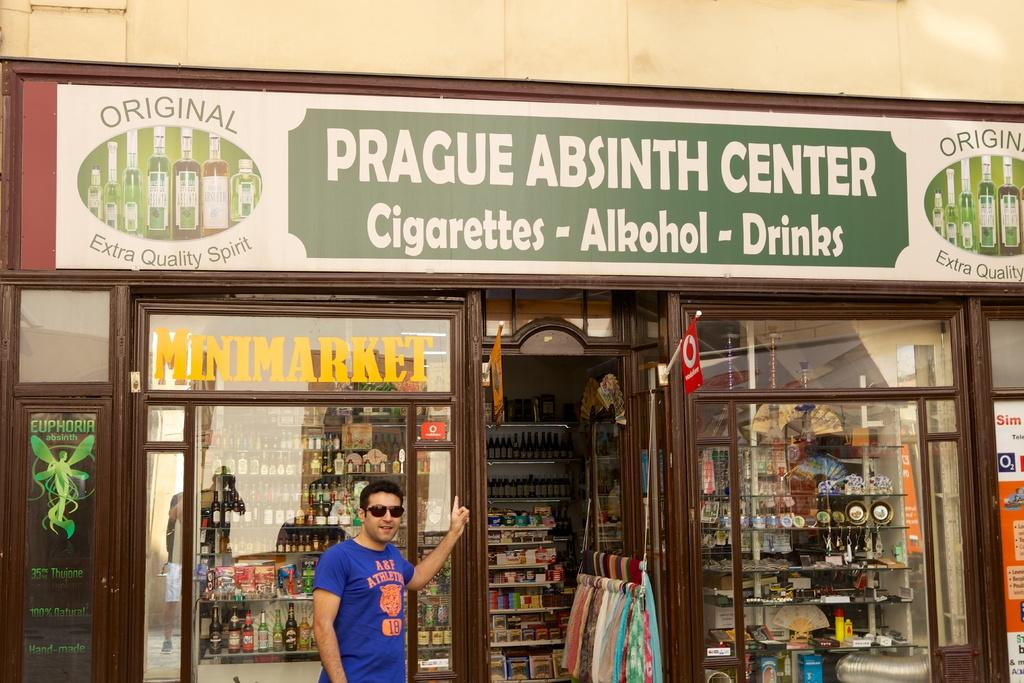<image>
Relay a brief, clear account of the picture shown. Store Sign that has the wording Prague Absinth Center Cigarettes-Alkohol-Drinks and is from Original Extra Quality Spirit. 